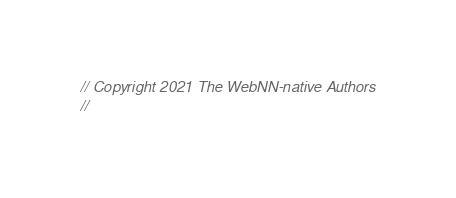<code> <loc_0><loc_0><loc_500><loc_500><_C_>// Copyright 2021 The WebNN-native Authors
//</code> 